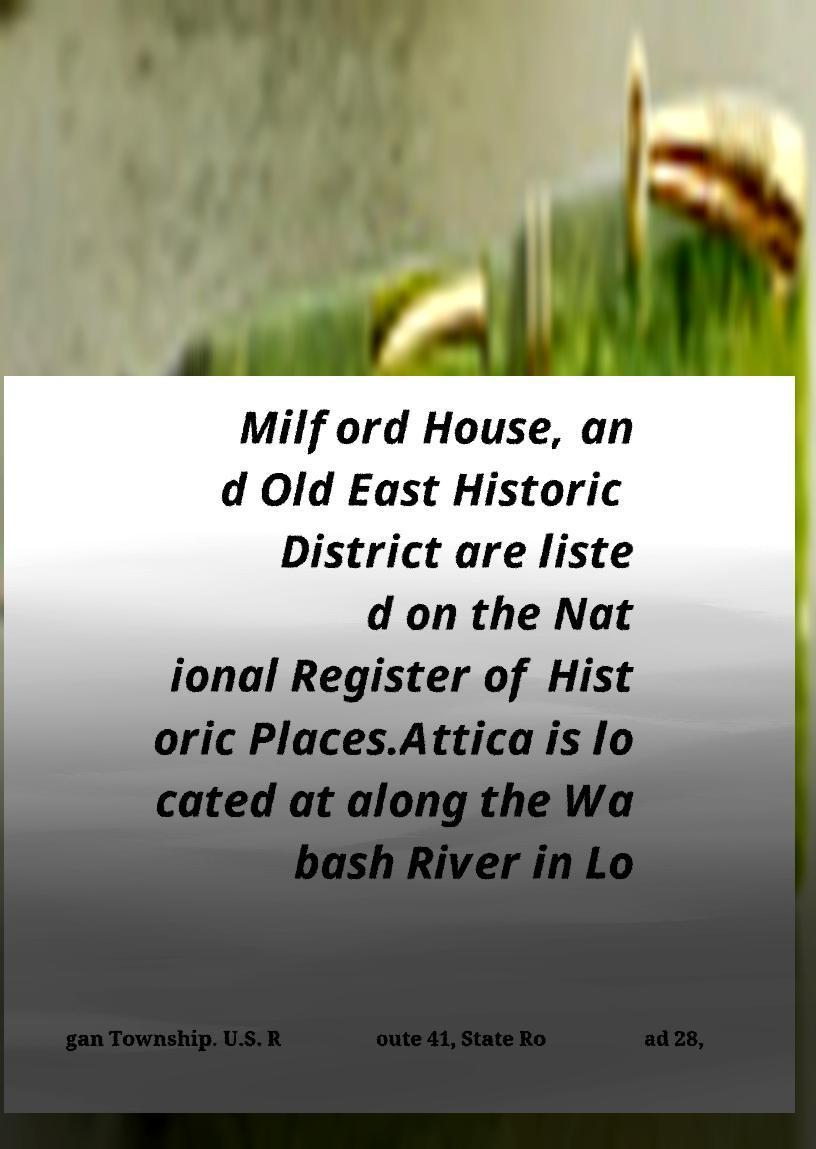Can you accurately transcribe the text from the provided image for me? Milford House, an d Old East Historic District are liste d on the Nat ional Register of Hist oric Places.Attica is lo cated at along the Wa bash River in Lo gan Township. U.S. R oute 41, State Ro ad 28, 